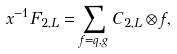<formula> <loc_0><loc_0><loc_500><loc_500>x ^ { - 1 } F _ { 2 , L } = \sum _ { f = q , g } C _ { 2 , L } \otimes f ,</formula> 